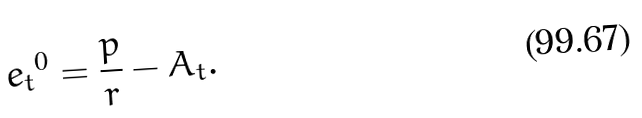Convert formula to latex. <formula><loc_0><loc_0><loc_500><loc_500>{ e _ { t } } ^ { 0 } = \frac { p } { r } - A _ { t } .</formula> 